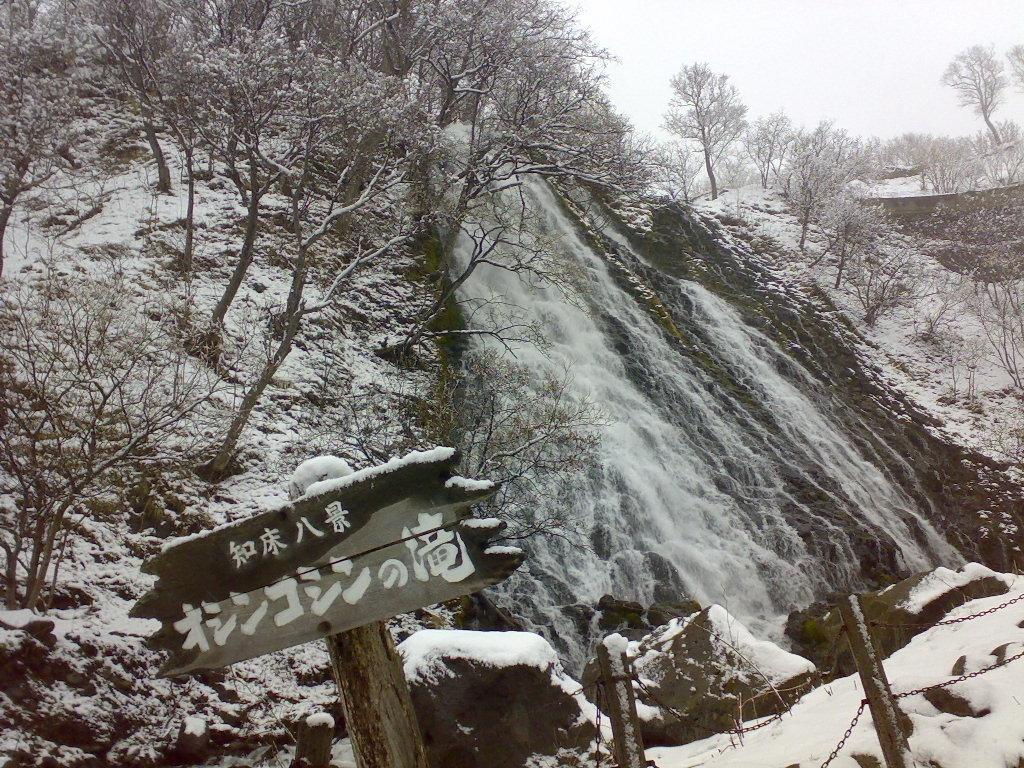Describe this image in one or two sentences. In this picture, we can see a wooden pole with a board and beside the pole there is a fence, trees, snow and sky. 